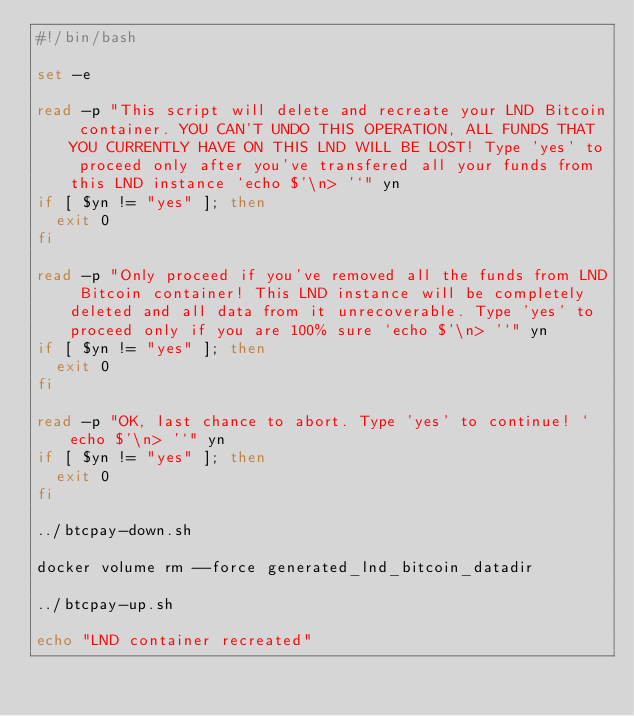Convert code to text. <code><loc_0><loc_0><loc_500><loc_500><_Bash_>#!/bin/bash

set -e

read -p "This script will delete and recreate your LND Bitcoin container. YOU CAN'T UNDO THIS OPERATION, ALL FUNDS THAT YOU CURRENTLY HAVE ON THIS LND WILL BE LOST! Type 'yes' to proceed only after you've transfered all your funds from this LND instance `echo $'\n> '`" yn
if [ $yn != "yes" ]; then
	exit 0
fi

read -p "Only proceed if you've removed all the funds from LND Bitcoin container! This LND instance will be completely deleted and all data from it unrecoverable. Type 'yes' to proceed only if you are 100% sure `echo $'\n> '`" yn
if [ $yn != "yes" ]; then
	exit 0
fi

read -p "OK, last chance to abort. Type 'yes' to continue! `echo $'\n> '`" yn
if [ $yn != "yes" ]; then
	exit 0
fi

../btcpay-down.sh

docker volume rm --force generated_lnd_bitcoin_datadir

../btcpay-up.sh

echo "LND container recreated"</code> 